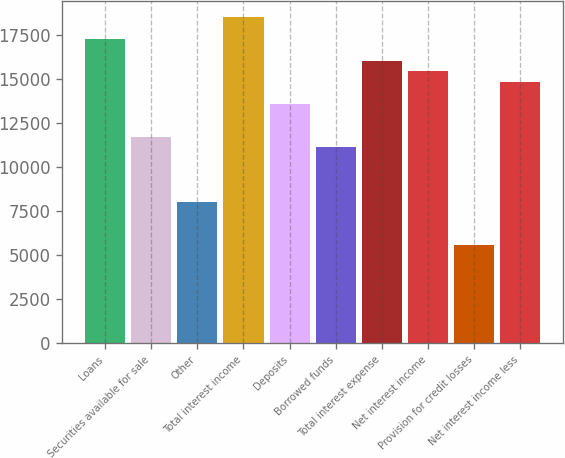<chart> <loc_0><loc_0><loc_500><loc_500><bar_chart><fcel>Loans<fcel>Securities available for sale<fcel>Other<fcel>Total interest income<fcel>Deposits<fcel>Borrowed funds<fcel>Total interest expense<fcel>Net interest income<fcel>Provision for credit losses<fcel>Net interest income less<nl><fcel>17256.9<fcel>11711.5<fcel>8014.52<fcel>18489.3<fcel>13560<fcel>11095.3<fcel>16024.6<fcel>15408.5<fcel>5549.85<fcel>14792.3<nl></chart> 